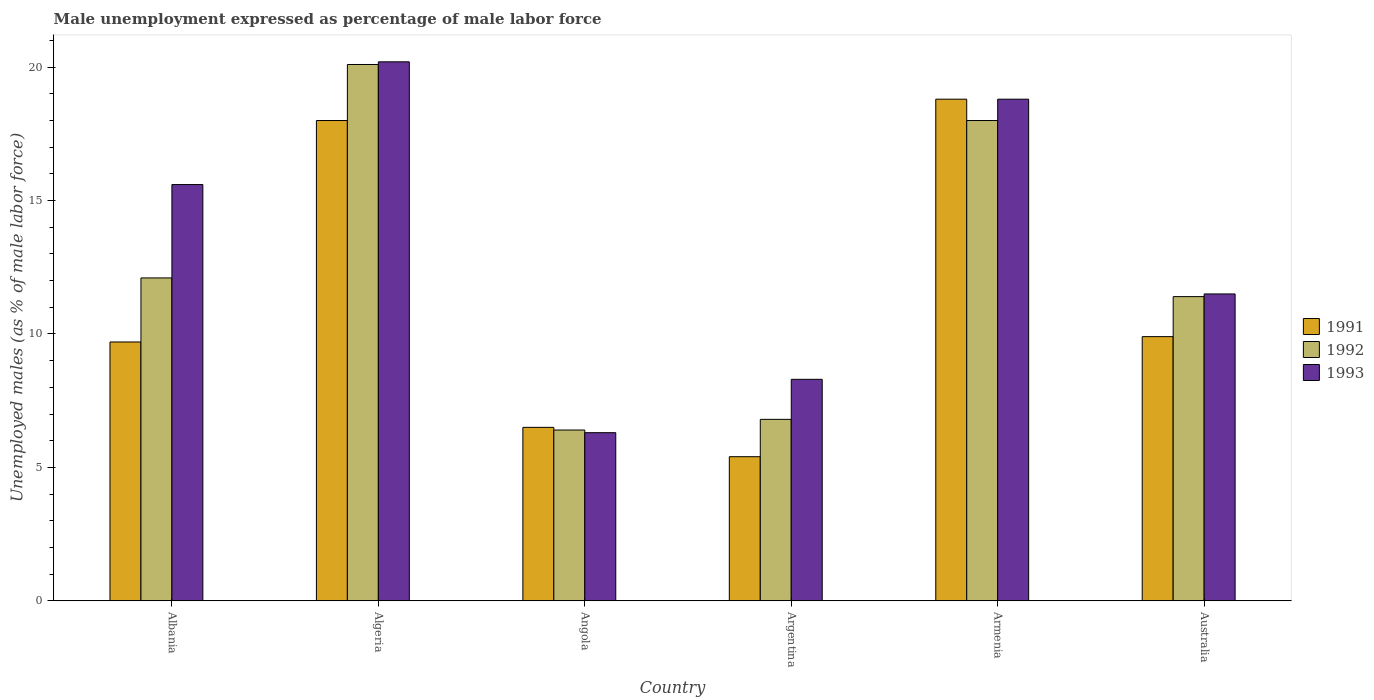Are the number of bars on each tick of the X-axis equal?
Your answer should be compact. Yes. What is the label of the 1st group of bars from the left?
Ensure brevity in your answer.  Albania. What is the unemployment in males in in 1993 in Angola?
Your answer should be very brief. 6.3. Across all countries, what is the maximum unemployment in males in in 1991?
Provide a short and direct response. 18.8. Across all countries, what is the minimum unemployment in males in in 1991?
Offer a terse response. 5.4. In which country was the unemployment in males in in 1993 maximum?
Make the answer very short. Algeria. In which country was the unemployment in males in in 1993 minimum?
Provide a short and direct response. Angola. What is the total unemployment in males in in 1992 in the graph?
Give a very brief answer. 74.8. What is the difference between the unemployment in males in in 1991 in Angola and that in Armenia?
Offer a terse response. -12.3. What is the difference between the unemployment in males in in 1993 in Argentina and the unemployment in males in in 1992 in Angola?
Give a very brief answer. 1.9. What is the average unemployment in males in in 1991 per country?
Offer a terse response. 11.38. What is the difference between the unemployment in males in of/in 1991 and unemployment in males in of/in 1992 in Albania?
Keep it short and to the point. -2.4. What is the ratio of the unemployment in males in in 1992 in Argentina to that in Armenia?
Ensure brevity in your answer.  0.38. Is the unemployment in males in in 1991 in Albania less than that in Australia?
Offer a very short reply. Yes. Is the difference between the unemployment in males in in 1991 in Albania and Australia greater than the difference between the unemployment in males in in 1992 in Albania and Australia?
Offer a very short reply. No. What is the difference between the highest and the second highest unemployment in males in in 1993?
Your response must be concise. -1.4. What is the difference between the highest and the lowest unemployment in males in in 1991?
Offer a very short reply. 13.4. In how many countries, is the unemployment in males in in 1991 greater than the average unemployment in males in in 1991 taken over all countries?
Make the answer very short. 2. Is the sum of the unemployment in males in in 1991 in Angola and Armenia greater than the maximum unemployment in males in in 1993 across all countries?
Offer a terse response. Yes. What does the 2nd bar from the right in Argentina represents?
Offer a terse response. 1992. Is it the case that in every country, the sum of the unemployment in males in in 1991 and unemployment in males in in 1992 is greater than the unemployment in males in in 1993?
Your response must be concise. Yes. Are all the bars in the graph horizontal?
Provide a short and direct response. No. How many countries are there in the graph?
Give a very brief answer. 6. Are the values on the major ticks of Y-axis written in scientific E-notation?
Offer a terse response. No. How many legend labels are there?
Make the answer very short. 3. What is the title of the graph?
Offer a very short reply. Male unemployment expressed as percentage of male labor force. Does "1988" appear as one of the legend labels in the graph?
Give a very brief answer. No. What is the label or title of the Y-axis?
Offer a terse response. Unemployed males (as % of male labor force). What is the Unemployed males (as % of male labor force) of 1991 in Albania?
Your response must be concise. 9.7. What is the Unemployed males (as % of male labor force) of 1992 in Albania?
Ensure brevity in your answer.  12.1. What is the Unemployed males (as % of male labor force) of 1993 in Albania?
Your answer should be compact. 15.6. What is the Unemployed males (as % of male labor force) in 1991 in Algeria?
Your answer should be very brief. 18. What is the Unemployed males (as % of male labor force) in 1992 in Algeria?
Keep it short and to the point. 20.1. What is the Unemployed males (as % of male labor force) in 1993 in Algeria?
Offer a terse response. 20.2. What is the Unemployed males (as % of male labor force) in 1992 in Angola?
Give a very brief answer. 6.4. What is the Unemployed males (as % of male labor force) of 1993 in Angola?
Provide a succinct answer. 6.3. What is the Unemployed males (as % of male labor force) in 1991 in Argentina?
Your answer should be compact. 5.4. What is the Unemployed males (as % of male labor force) of 1992 in Argentina?
Keep it short and to the point. 6.8. What is the Unemployed males (as % of male labor force) of 1993 in Argentina?
Give a very brief answer. 8.3. What is the Unemployed males (as % of male labor force) of 1991 in Armenia?
Provide a short and direct response. 18.8. What is the Unemployed males (as % of male labor force) of 1993 in Armenia?
Give a very brief answer. 18.8. What is the Unemployed males (as % of male labor force) in 1991 in Australia?
Make the answer very short. 9.9. What is the Unemployed males (as % of male labor force) in 1992 in Australia?
Make the answer very short. 11.4. Across all countries, what is the maximum Unemployed males (as % of male labor force) of 1991?
Keep it short and to the point. 18.8. Across all countries, what is the maximum Unemployed males (as % of male labor force) in 1992?
Provide a short and direct response. 20.1. Across all countries, what is the maximum Unemployed males (as % of male labor force) of 1993?
Your answer should be very brief. 20.2. Across all countries, what is the minimum Unemployed males (as % of male labor force) of 1991?
Give a very brief answer. 5.4. Across all countries, what is the minimum Unemployed males (as % of male labor force) of 1992?
Your answer should be very brief. 6.4. Across all countries, what is the minimum Unemployed males (as % of male labor force) in 1993?
Provide a short and direct response. 6.3. What is the total Unemployed males (as % of male labor force) in 1991 in the graph?
Keep it short and to the point. 68.3. What is the total Unemployed males (as % of male labor force) in 1992 in the graph?
Your response must be concise. 74.8. What is the total Unemployed males (as % of male labor force) in 1993 in the graph?
Make the answer very short. 80.7. What is the difference between the Unemployed males (as % of male labor force) of 1992 in Albania and that in Algeria?
Your response must be concise. -8. What is the difference between the Unemployed males (as % of male labor force) in 1993 in Albania and that in Algeria?
Keep it short and to the point. -4.6. What is the difference between the Unemployed males (as % of male labor force) in 1991 in Albania and that in Angola?
Ensure brevity in your answer.  3.2. What is the difference between the Unemployed males (as % of male labor force) of 1993 in Albania and that in Angola?
Your answer should be compact. 9.3. What is the difference between the Unemployed males (as % of male labor force) in 1991 in Albania and that in Argentina?
Provide a succinct answer. 4.3. What is the difference between the Unemployed males (as % of male labor force) in 1992 in Albania and that in Argentina?
Your answer should be compact. 5.3. What is the difference between the Unemployed males (as % of male labor force) in 1993 in Albania and that in Armenia?
Your answer should be very brief. -3.2. What is the difference between the Unemployed males (as % of male labor force) of 1991 in Albania and that in Australia?
Keep it short and to the point. -0.2. What is the difference between the Unemployed males (as % of male labor force) of 1992 in Albania and that in Australia?
Your answer should be very brief. 0.7. What is the difference between the Unemployed males (as % of male labor force) of 1993 in Albania and that in Australia?
Keep it short and to the point. 4.1. What is the difference between the Unemployed males (as % of male labor force) of 1993 in Algeria and that in Angola?
Ensure brevity in your answer.  13.9. What is the difference between the Unemployed males (as % of male labor force) in 1991 in Algeria and that in Argentina?
Your response must be concise. 12.6. What is the difference between the Unemployed males (as % of male labor force) in 1992 in Algeria and that in Argentina?
Provide a succinct answer. 13.3. What is the difference between the Unemployed males (as % of male labor force) in 1993 in Algeria and that in Argentina?
Your answer should be compact. 11.9. What is the difference between the Unemployed males (as % of male labor force) of 1991 in Algeria and that in Armenia?
Make the answer very short. -0.8. What is the difference between the Unemployed males (as % of male labor force) of 1992 in Algeria and that in Armenia?
Your answer should be compact. 2.1. What is the difference between the Unemployed males (as % of male labor force) of 1993 in Algeria and that in Armenia?
Provide a succinct answer. 1.4. What is the difference between the Unemployed males (as % of male labor force) of 1991 in Algeria and that in Australia?
Provide a succinct answer. 8.1. What is the difference between the Unemployed males (as % of male labor force) in 1993 in Algeria and that in Australia?
Make the answer very short. 8.7. What is the difference between the Unemployed males (as % of male labor force) of 1991 in Angola and that in Argentina?
Your answer should be compact. 1.1. What is the difference between the Unemployed males (as % of male labor force) of 1992 in Angola and that in Argentina?
Your response must be concise. -0.4. What is the difference between the Unemployed males (as % of male labor force) in 1991 in Angola and that in Armenia?
Your answer should be compact. -12.3. What is the difference between the Unemployed males (as % of male labor force) of 1993 in Angola and that in Armenia?
Offer a terse response. -12.5. What is the difference between the Unemployed males (as % of male labor force) of 1991 in Angola and that in Australia?
Your response must be concise. -3.4. What is the difference between the Unemployed males (as % of male labor force) of 1992 in Angola and that in Australia?
Keep it short and to the point. -5. What is the difference between the Unemployed males (as % of male labor force) of 1991 in Argentina and that in Australia?
Offer a terse response. -4.5. What is the difference between the Unemployed males (as % of male labor force) in 1992 in Argentina and that in Australia?
Provide a succinct answer. -4.6. What is the difference between the Unemployed males (as % of male labor force) in 1993 in Argentina and that in Australia?
Offer a terse response. -3.2. What is the difference between the Unemployed males (as % of male labor force) of 1991 in Armenia and that in Australia?
Provide a short and direct response. 8.9. What is the difference between the Unemployed males (as % of male labor force) of 1993 in Armenia and that in Australia?
Offer a terse response. 7.3. What is the difference between the Unemployed males (as % of male labor force) of 1991 in Albania and the Unemployed males (as % of male labor force) of 1992 in Algeria?
Your answer should be compact. -10.4. What is the difference between the Unemployed males (as % of male labor force) in 1992 in Albania and the Unemployed males (as % of male labor force) in 1993 in Algeria?
Give a very brief answer. -8.1. What is the difference between the Unemployed males (as % of male labor force) of 1991 in Albania and the Unemployed males (as % of male labor force) of 1993 in Angola?
Make the answer very short. 3.4. What is the difference between the Unemployed males (as % of male labor force) in 1991 in Albania and the Unemployed males (as % of male labor force) in 1992 in Argentina?
Give a very brief answer. 2.9. What is the difference between the Unemployed males (as % of male labor force) of 1991 in Albania and the Unemployed males (as % of male labor force) of 1993 in Armenia?
Give a very brief answer. -9.1. What is the difference between the Unemployed males (as % of male labor force) of 1992 in Albania and the Unemployed males (as % of male labor force) of 1993 in Armenia?
Provide a succinct answer. -6.7. What is the difference between the Unemployed males (as % of male labor force) of 1991 in Albania and the Unemployed males (as % of male labor force) of 1992 in Australia?
Offer a terse response. -1.7. What is the difference between the Unemployed males (as % of male labor force) of 1991 in Algeria and the Unemployed males (as % of male labor force) of 1992 in Angola?
Offer a terse response. 11.6. What is the difference between the Unemployed males (as % of male labor force) in 1992 in Algeria and the Unemployed males (as % of male labor force) in 1993 in Angola?
Keep it short and to the point. 13.8. What is the difference between the Unemployed males (as % of male labor force) of 1991 in Algeria and the Unemployed males (as % of male labor force) of 1993 in Argentina?
Your answer should be compact. 9.7. What is the difference between the Unemployed males (as % of male labor force) of 1992 in Algeria and the Unemployed males (as % of male labor force) of 1993 in Argentina?
Your answer should be very brief. 11.8. What is the difference between the Unemployed males (as % of male labor force) in 1991 in Algeria and the Unemployed males (as % of male labor force) in 1992 in Armenia?
Provide a succinct answer. 0. What is the difference between the Unemployed males (as % of male labor force) of 1992 in Algeria and the Unemployed males (as % of male labor force) of 1993 in Armenia?
Make the answer very short. 1.3. What is the difference between the Unemployed males (as % of male labor force) of 1991 in Algeria and the Unemployed males (as % of male labor force) of 1992 in Australia?
Keep it short and to the point. 6.6. What is the difference between the Unemployed males (as % of male labor force) of 1991 in Angola and the Unemployed males (as % of male labor force) of 1993 in Argentina?
Your response must be concise. -1.8. What is the difference between the Unemployed males (as % of male labor force) in 1991 in Angola and the Unemployed males (as % of male labor force) in 1992 in Armenia?
Keep it short and to the point. -11.5. What is the difference between the Unemployed males (as % of male labor force) in 1991 in Angola and the Unemployed males (as % of male labor force) in 1993 in Armenia?
Make the answer very short. -12.3. What is the difference between the Unemployed males (as % of male labor force) of 1992 in Angola and the Unemployed males (as % of male labor force) of 1993 in Armenia?
Make the answer very short. -12.4. What is the difference between the Unemployed males (as % of male labor force) in 1991 in Angola and the Unemployed males (as % of male labor force) in 1993 in Australia?
Give a very brief answer. -5. What is the difference between the Unemployed males (as % of male labor force) of 1991 in Argentina and the Unemployed males (as % of male labor force) of 1992 in Armenia?
Offer a very short reply. -12.6. What is the difference between the Unemployed males (as % of male labor force) of 1992 in Argentina and the Unemployed males (as % of male labor force) of 1993 in Armenia?
Make the answer very short. -12. What is the difference between the Unemployed males (as % of male labor force) in 1991 in Argentina and the Unemployed males (as % of male labor force) in 1992 in Australia?
Provide a short and direct response. -6. What is the difference between the Unemployed males (as % of male labor force) in 1991 in Argentina and the Unemployed males (as % of male labor force) in 1993 in Australia?
Give a very brief answer. -6.1. What is the difference between the Unemployed males (as % of male labor force) of 1992 in Argentina and the Unemployed males (as % of male labor force) of 1993 in Australia?
Give a very brief answer. -4.7. What is the difference between the Unemployed males (as % of male labor force) in 1991 in Armenia and the Unemployed males (as % of male labor force) in 1992 in Australia?
Keep it short and to the point. 7.4. What is the difference between the Unemployed males (as % of male labor force) of 1992 in Armenia and the Unemployed males (as % of male labor force) of 1993 in Australia?
Your response must be concise. 6.5. What is the average Unemployed males (as % of male labor force) in 1991 per country?
Provide a succinct answer. 11.38. What is the average Unemployed males (as % of male labor force) of 1992 per country?
Give a very brief answer. 12.47. What is the average Unemployed males (as % of male labor force) of 1993 per country?
Provide a succinct answer. 13.45. What is the difference between the Unemployed males (as % of male labor force) of 1991 and Unemployed males (as % of male labor force) of 1992 in Algeria?
Give a very brief answer. -2.1. What is the difference between the Unemployed males (as % of male labor force) in 1991 and Unemployed males (as % of male labor force) in 1993 in Algeria?
Provide a succinct answer. -2.2. What is the difference between the Unemployed males (as % of male labor force) in 1991 and Unemployed males (as % of male labor force) in 1993 in Angola?
Make the answer very short. 0.2. What is the difference between the Unemployed males (as % of male labor force) in 1991 and Unemployed males (as % of male labor force) in 1992 in Argentina?
Provide a succinct answer. -1.4. What is the difference between the Unemployed males (as % of male labor force) of 1991 and Unemployed males (as % of male labor force) of 1993 in Argentina?
Ensure brevity in your answer.  -2.9. What is the difference between the Unemployed males (as % of male labor force) in 1992 and Unemployed males (as % of male labor force) in 1993 in Armenia?
Your response must be concise. -0.8. What is the ratio of the Unemployed males (as % of male labor force) of 1991 in Albania to that in Algeria?
Provide a succinct answer. 0.54. What is the ratio of the Unemployed males (as % of male labor force) of 1992 in Albania to that in Algeria?
Your response must be concise. 0.6. What is the ratio of the Unemployed males (as % of male labor force) in 1993 in Albania to that in Algeria?
Ensure brevity in your answer.  0.77. What is the ratio of the Unemployed males (as % of male labor force) in 1991 in Albania to that in Angola?
Offer a very short reply. 1.49. What is the ratio of the Unemployed males (as % of male labor force) of 1992 in Albania to that in Angola?
Offer a terse response. 1.89. What is the ratio of the Unemployed males (as % of male labor force) in 1993 in Albania to that in Angola?
Offer a terse response. 2.48. What is the ratio of the Unemployed males (as % of male labor force) of 1991 in Albania to that in Argentina?
Offer a very short reply. 1.8. What is the ratio of the Unemployed males (as % of male labor force) of 1992 in Albania to that in Argentina?
Offer a very short reply. 1.78. What is the ratio of the Unemployed males (as % of male labor force) in 1993 in Albania to that in Argentina?
Your response must be concise. 1.88. What is the ratio of the Unemployed males (as % of male labor force) of 1991 in Albania to that in Armenia?
Offer a very short reply. 0.52. What is the ratio of the Unemployed males (as % of male labor force) in 1992 in Albania to that in Armenia?
Provide a short and direct response. 0.67. What is the ratio of the Unemployed males (as % of male labor force) of 1993 in Albania to that in Armenia?
Provide a succinct answer. 0.83. What is the ratio of the Unemployed males (as % of male labor force) in 1991 in Albania to that in Australia?
Your response must be concise. 0.98. What is the ratio of the Unemployed males (as % of male labor force) in 1992 in Albania to that in Australia?
Provide a succinct answer. 1.06. What is the ratio of the Unemployed males (as % of male labor force) of 1993 in Albania to that in Australia?
Your answer should be very brief. 1.36. What is the ratio of the Unemployed males (as % of male labor force) of 1991 in Algeria to that in Angola?
Your response must be concise. 2.77. What is the ratio of the Unemployed males (as % of male labor force) of 1992 in Algeria to that in Angola?
Ensure brevity in your answer.  3.14. What is the ratio of the Unemployed males (as % of male labor force) in 1993 in Algeria to that in Angola?
Keep it short and to the point. 3.21. What is the ratio of the Unemployed males (as % of male labor force) in 1992 in Algeria to that in Argentina?
Offer a very short reply. 2.96. What is the ratio of the Unemployed males (as % of male labor force) in 1993 in Algeria to that in Argentina?
Your answer should be compact. 2.43. What is the ratio of the Unemployed males (as % of male labor force) in 1991 in Algeria to that in Armenia?
Offer a terse response. 0.96. What is the ratio of the Unemployed males (as % of male labor force) in 1992 in Algeria to that in Armenia?
Your answer should be compact. 1.12. What is the ratio of the Unemployed males (as % of male labor force) of 1993 in Algeria to that in Armenia?
Offer a very short reply. 1.07. What is the ratio of the Unemployed males (as % of male labor force) of 1991 in Algeria to that in Australia?
Your answer should be compact. 1.82. What is the ratio of the Unemployed males (as % of male labor force) of 1992 in Algeria to that in Australia?
Ensure brevity in your answer.  1.76. What is the ratio of the Unemployed males (as % of male labor force) in 1993 in Algeria to that in Australia?
Your response must be concise. 1.76. What is the ratio of the Unemployed males (as % of male labor force) of 1991 in Angola to that in Argentina?
Give a very brief answer. 1.2. What is the ratio of the Unemployed males (as % of male labor force) in 1993 in Angola to that in Argentina?
Make the answer very short. 0.76. What is the ratio of the Unemployed males (as % of male labor force) of 1991 in Angola to that in Armenia?
Your answer should be compact. 0.35. What is the ratio of the Unemployed males (as % of male labor force) in 1992 in Angola to that in Armenia?
Keep it short and to the point. 0.36. What is the ratio of the Unemployed males (as % of male labor force) of 1993 in Angola to that in Armenia?
Offer a terse response. 0.34. What is the ratio of the Unemployed males (as % of male labor force) in 1991 in Angola to that in Australia?
Your answer should be very brief. 0.66. What is the ratio of the Unemployed males (as % of male labor force) in 1992 in Angola to that in Australia?
Keep it short and to the point. 0.56. What is the ratio of the Unemployed males (as % of male labor force) in 1993 in Angola to that in Australia?
Make the answer very short. 0.55. What is the ratio of the Unemployed males (as % of male labor force) of 1991 in Argentina to that in Armenia?
Provide a succinct answer. 0.29. What is the ratio of the Unemployed males (as % of male labor force) of 1992 in Argentina to that in Armenia?
Offer a terse response. 0.38. What is the ratio of the Unemployed males (as % of male labor force) of 1993 in Argentina to that in Armenia?
Offer a terse response. 0.44. What is the ratio of the Unemployed males (as % of male labor force) in 1991 in Argentina to that in Australia?
Your answer should be very brief. 0.55. What is the ratio of the Unemployed males (as % of male labor force) in 1992 in Argentina to that in Australia?
Your answer should be very brief. 0.6. What is the ratio of the Unemployed males (as % of male labor force) in 1993 in Argentina to that in Australia?
Provide a short and direct response. 0.72. What is the ratio of the Unemployed males (as % of male labor force) in 1991 in Armenia to that in Australia?
Offer a terse response. 1.9. What is the ratio of the Unemployed males (as % of male labor force) in 1992 in Armenia to that in Australia?
Your answer should be compact. 1.58. What is the ratio of the Unemployed males (as % of male labor force) of 1993 in Armenia to that in Australia?
Give a very brief answer. 1.63. What is the difference between the highest and the second highest Unemployed males (as % of male labor force) of 1991?
Your response must be concise. 0.8. What is the difference between the highest and the second highest Unemployed males (as % of male labor force) of 1992?
Offer a very short reply. 2.1. What is the difference between the highest and the second highest Unemployed males (as % of male labor force) in 1993?
Offer a very short reply. 1.4. What is the difference between the highest and the lowest Unemployed males (as % of male labor force) of 1993?
Your answer should be compact. 13.9. 